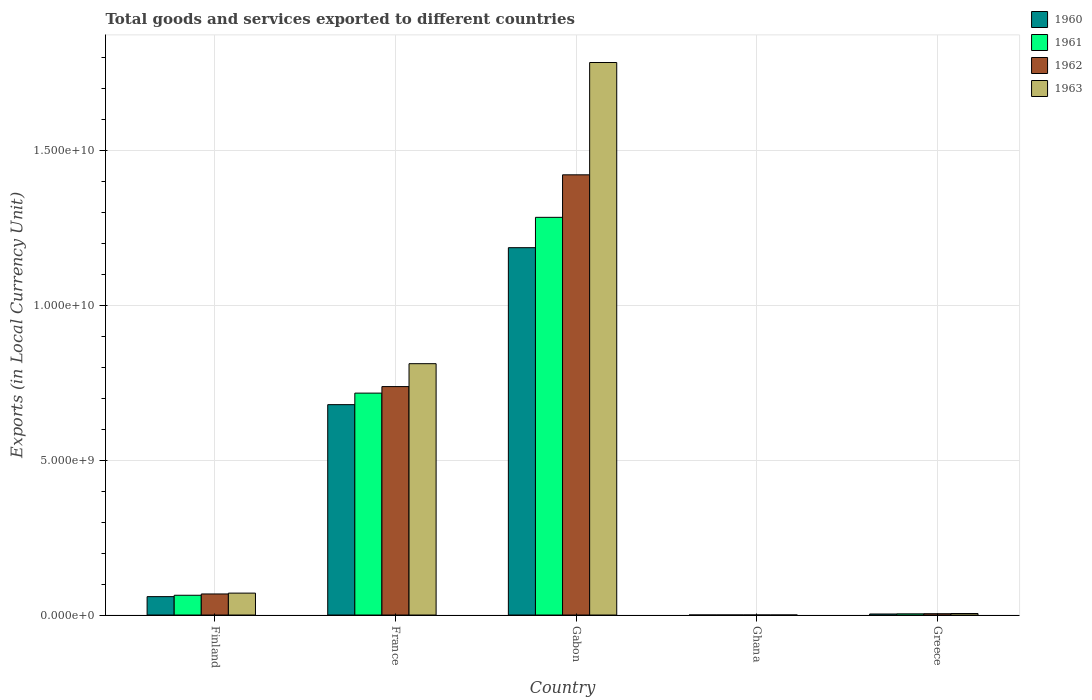How many different coloured bars are there?
Offer a very short reply. 4. Are the number of bars per tick equal to the number of legend labels?
Make the answer very short. Yes. In how many cases, is the number of bars for a given country not equal to the number of legend labels?
Your response must be concise. 0. What is the Amount of goods and services exports in 1963 in Greece?
Offer a very short reply. 4.90e+07. Across all countries, what is the maximum Amount of goods and services exports in 1962?
Offer a terse response. 1.42e+1. Across all countries, what is the minimum Amount of goods and services exports in 1961?
Your answer should be compact. 2.43e+04. In which country was the Amount of goods and services exports in 1963 maximum?
Offer a terse response. Gabon. What is the total Amount of goods and services exports in 1962 in the graph?
Your response must be concise. 2.23e+1. What is the difference between the Amount of goods and services exports in 1960 in Ghana and that in Greece?
Offer a terse response. -3.33e+07. What is the difference between the Amount of goods and services exports in 1962 in Gabon and the Amount of goods and services exports in 1963 in Finland?
Keep it short and to the point. 1.35e+1. What is the average Amount of goods and services exports in 1963 per country?
Your answer should be very brief. 5.34e+09. What is the difference between the Amount of goods and services exports of/in 1962 and Amount of goods and services exports of/in 1961 in France?
Ensure brevity in your answer.  2.11e+08. In how many countries, is the Amount of goods and services exports in 1963 greater than 8000000000 LCU?
Give a very brief answer. 2. What is the ratio of the Amount of goods and services exports in 1963 in Finland to that in Greece?
Offer a very short reply. 14.43. Is the Amount of goods and services exports in 1961 in France less than that in Gabon?
Keep it short and to the point. Yes. What is the difference between the highest and the second highest Amount of goods and services exports in 1960?
Make the answer very short. 6.19e+09. What is the difference between the highest and the lowest Amount of goods and services exports in 1960?
Your response must be concise. 1.19e+1. What does the 2nd bar from the left in Ghana represents?
Give a very brief answer. 1961. Is it the case that in every country, the sum of the Amount of goods and services exports in 1961 and Amount of goods and services exports in 1960 is greater than the Amount of goods and services exports in 1962?
Provide a short and direct response. Yes. Are the values on the major ticks of Y-axis written in scientific E-notation?
Your response must be concise. Yes. Does the graph contain any zero values?
Offer a very short reply. No. Does the graph contain grids?
Give a very brief answer. Yes. Where does the legend appear in the graph?
Provide a succinct answer. Top right. How are the legend labels stacked?
Give a very brief answer. Vertical. What is the title of the graph?
Make the answer very short. Total goods and services exported to different countries. What is the label or title of the Y-axis?
Your response must be concise. Exports (in Local Currency Unit). What is the Exports (in Local Currency Unit) in 1960 in Finland?
Provide a succinct answer. 5.94e+08. What is the Exports (in Local Currency Unit) in 1961 in Finland?
Give a very brief answer. 6.38e+08. What is the Exports (in Local Currency Unit) of 1962 in Finland?
Your answer should be very brief. 6.80e+08. What is the Exports (in Local Currency Unit) in 1963 in Finland?
Make the answer very short. 7.07e+08. What is the Exports (in Local Currency Unit) of 1960 in France?
Provide a succinct answer. 6.79e+09. What is the Exports (in Local Currency Unit) of 1961 in France?
Offer a very short reply. 7.16e+09. What is the Exports (in Local Currency Unit) in 1962 in France?
Provide a short and direct response. 7.37e+09. What is the Exports (in Local Currency Unit) in 1963 in France?
Offer a terse response. 8.11e+09. What is the Exports (in Local Currency Unit) in 1960 in Gabon?
Give a very brief answer. 1.19e+1. What is the Exports (in Local Currency Unit) of 1961 in Gabon?
Keep it short and to the point. 1.28e+1. What is the Exports (in Local Currency Unit) in 1962 in Gabon?
Offer a very short reply. 1.42e+1. What is the Exports (in Local Currency Unit) of 1963 in Gabon?
Provide a short and direct response. 1.78e+1. What is the Exports (in Local Currency Unit) in 1960 in Ghana?
Make the answer very short. 2.45e+04. What is the Exports (in Local Currency Unit) of 1961 in Ghana?
Your answer should be compact. 2.43e+04. What is the Exports (in Local Currency Unit) in 1962 in Ghana?
Your answer should be very brief. 2.39e+04. What is the Exports (in Local Currency Unit) in 1963 in Ghana?
Offer a terse response. 2.33e+04. What is the Exports (in Local Currency Unit) in 1960 in Greece?
Provide a short and direct response. 3.33e+07. What is the Exports (in Local Currency Unit) of 1961 in Greece?
Offer a very short reply. 3.82e+07. What is the Exports (in Local Currency Unit) of 1962 in Greece?
Make the answer very short. 4.25e+07. What is the Exports (in Local Currency Unit) of 1963 in Greece?
Your answer should be compact. 4.90e+07. Across all countries, what is the maximum Exports (in Local Currency Unit) of 1960?
Your response must be concise. 1.19e+1. Across all countries, what is the maximum Exports (in Local Currency Unit) of 1961?
Offer a terse response. 1.28e+1. Across all countries, what is the maximum Exports (in Local Currency Unit) in 1962?
Give a very brief answer. 1.42e+1. Across all countries, what is the maximum Exports (in Local Currency Unit) in 1963?
Provide a short and direct response. 1.78e+1. Across all countries, what is the minimum Exports (in Local Currency Unit) of 1960?
Your answer should be compact. 2.45e+04. Across all countries, what is the minimum Exports (in Local Currency Unit) in 1961?
Offer a terse response. 2.43e+04. Across all countries, what is the minimum Exports (in Local Currency Unit) of 1962?
Give a very brief answer. 2.39e+04. Across all countries, what is the minimum Exports (in Local Currency Unit) in 1963?
Give a very brief answer. 2.33e+04. What is the total Exports (in Local Currency Unit) in 1960 in the graph?
Keep it short and to the point. 1.93e+1. What is the total Exports (in Local Currency Unit) in 1961 in the graph?
Your answer should be compact. 2.07e+1. What is the total Exports (in Local Currency Unit) of 1962 in the graph?
Give a very brief answer. 2.23e+1. What is the total Exports (in Local Currency Unit) in 1963 in the graph?
Your answer should be very brief. 2.67e+1. What is the difference between the Exports (in Local Currency Unit) of 1960 in Finland and that in France?
Offer a very short reply. -6.19e+09. What is the difference between the Exports (in Local Currency Unit) of 1961 in Finland and that in France?
Your answer should be compact. -6.52e+09. What is the difference between the Exports (in Local Currency Unit) in 1962 in Finland and that in France?
Keep it short and to the point. -6.69e+09. What is the difference between the Exports (in Local Currency Unit) of 1963 in Finland and that in France?
Make the answer very short. -7.40e+09. What is the difference between the Exports (in Local Currency Unit) of 1960 in Finland and that in Gabon?
Offer a terse response. -1.13e+1. What is the difference between the Exports (in Local Currency Unit) of 1961 in Finland and that in Gabon?
Provide a short and direct response. -1.22e+1. What is the difference between the Exports (in Local Currency Unit) of 1962 in Finland and that in Gabon?
Ensure brevity in your answer.  -1.35e+1. What is the difference between the Exports (in Local Currency Unit) of 1963 in Finland and that in Gabon?
Your answer should be compact. -1.71e+1. What is the difference between the Exports (in Local Currency Unit) of 1960 in Finland and that in Ghana?
Offer a terse response. 5.94e+08. What is the difference between the Exports (in Local Currency Unit) in 1961 in Finland and that in Ghana?
Your response must be concise. 6.38e+08. What is the difference between the Exports (in Local Currency Unit) in 1962 in Finland and that in Ghana?
Your response must be concise. 6.80e+08. What is the difference between the Exports (in Local Currency Unit) of 1963 in Finland and that in Ghana?
Your answer should be very brief. 7.07e+08. What is the difference between the Exports (in Local Currency Unit) in 1960 in Finland and that in Greece?
Offer a terse response. 5.60e+08. What is the difference between the Exports (in Local Currency Unit) of 1961 in Finland and that in Greece?
Give a very brief answer. 5.99e+08. What is the difference between the Exports (in Local Currency Unit) in 1962 in Finland and that in Greece?
Your answer should be compact. 6.37e+08. What is the difference between the Exports (in Local Currency Unit) of 1963 in Finland and that in Greece?
Give a very brief answer. 6.58e+08. What is the difference between the Exports (in Local Currency Unit) in 1960 in France and that in Gabon?
Your answer should be compact. -5.06e+09. What is the difference between the Exports (in Local Currency Unit) in 1961 in France and that in Gabon?
Offer a very short reply. -5.67e+09. What is the difference between the Exports (in Local Currency Unit) in 1962 in France and that in Gabon?
Provide a short and direct response. -6.83e+09. What is the difference between the Exports (in Local Currency Unit) of 1963 in France and that in Gabon?
Your answer should be compact. -9.72e+09. What is the difference between the Exports (in Local Currency Unit) of 1960 in France and that in Ghana?
Provide a short and direct response. 6.79e+09. What is the difference between the Exports (in Local Currency Unit) of 1961 in France and that in Ghana?
Keep it short and to the point. 7.16e+09. What is the difference between the Exports (in Local Currency Unit) of 1962 in France and that in Ghana?
Offer a terse response. 7.37e+09. What is the difference between the Exports (in Local Currency Unit) in 1963 in France and that in Ghana?
Make the answer very short. 8.11e+09. What is the difference between the Exports (in Local Currency Unit) of 1960 in France and that in Greece?
Offer a very short reply. 6.76e+09. What is the difference between the Exports (in Local Currency Unit) in 1961 in France and that in Greece?
Offer a very short reply. 7.12e+09. What is the difference between the Exports (in Local Currency Unit) in 1962 in France and that in Greece?
Offer a very short reply. 7.33e+09. What is the difference between the Exports (in Local Currency Unit) of 1963 in France and that in Greece?
Keep it short and to the point. 8.06e+09. What is the difference between the Exports (in Local Currency Unit) in 1960 in Gabon and that in Ghana?
Make the answer very short. 1.19e+1. What is the difference between the Exports (in Local Currency Unit) of 1961 in Gabon and that in Ghana?
Offer a terse response. 1.28e+1. What is the difference between the Exports (in Local Currency Unit) in 1962 in Gabon and that in Ghana?
Keep it short and to the point. 1.42e+1. What is the difference between the Exports (in Local Currency Unit) in 1963 in Gabon and that in Ghana?
Make the answer very short. 1.78e+1. What is the difference between the Exports (in Local Currency Unit) of 1960 in Gabon and that in Greece?
Provide a succinct answer. 1.18e+1. What is the difference between the Exports (in Local Currency Unit) of 1961 in Gabon and that in Greece?
Your answer should be very brief. 1.28e+1. What is the difference between the Exports (in Local Currency Unit) in 1962 in Gabon and that in Greece?
Your answer should be compact. 1.42e+1. What is the difference between the Exports (in Local Currency Unit) in 1963 in Gabon and that in Greece?
Your answer should be very brief. 1.78e+1. What is the difference between the Exports (in Local Currency Unit) of 1960 in Ghana and that in Greece?
Your answer should be compact. -3.33e+07. What is the difference between the Exports (in Local Currency Unit) in 1961 in Ghana and that in Greece?
Give a very brief answer. -3.82e+07. What is the difference between the Exports (in Local Currency Unit) of 1962 in Ghana and that in Greece?
Your response must be concise. -4.25e+07. What is the difference between the Exports (in Local Currency Unit) of 1963 in Ghana and that in Greece?
Ensure brevity in your answer.  -4.90e+07. What is the difference between the Exports (in Local Currency Unit) in 1960 in Finland and the Exports (in Local Currency Unit) in 1961 in France?
Your response must be concise. -6.57e+09. What is the difference between the Exports (in Local Currency Unit) in 1960 in Finland and the Exports (in Local Currency Unit) in 1962 in France?
Offer a very short reply. -6.78e+09. What is the difference between the Exports (in Local Currency Unit) of 1960 in Finland and the Exports (in Local Currency Unit) of 1963 in France?
Keep it short and to the point. -7.52e+09. What is the difference between the Exports (in Local Currency Unit) in 1961 in Finland and the Exports (in Local Currency Unit) in 1962 in France?
Provide a short and direct response. -6.73e+09. What is the difference between the Exports (in Local Currency Unit) of 1961 in Finland and the Exports (in Local Currency Unit) of 1963 in France?
Ensure brevity in your answer.  -7.47e+09. What is the difference between the Exports (in Local Currency Unit) in 1962 in Finland and the Exports (in Local Currency Unit) in 1963 in France?
Provide a short and direct response. -7.43e+09. What is the difference between the Exports (in Local Currency Unit) of 1960 in Finland and the Exports (in Local Currency Unit) of 1961 in Gabon?
Provide a short and direct response. -1.22e+1. What is the difference between the Exports (in Local Currency Unit) of 1960 in Finland and the Exports (in Local Currency Unit) of 1962 in Gabon?
Provide a succinct answer. -1.36e+1. What is the difference between the Exports (in Local Currency Unit) of 1960 in Finland and the Exports (in Local Currency Unit) of 1963 in Gabon?
Give a very brief answer. -1.72e+1. What is the difference between the Exports (in Local Currency Unit) in 1961 in Finland and the Exports (in Local Currency Unit) in 1962 in Gabon?
Ensure brevity in your answer.  -1.36e+1. What is the difference between the Exports (in Local Currency Unit) of 1961 in Finland and the Exports (in Local Currency Unit) of 1963 in Gabon?
Offer a terse response. -1.72e+1. What is the difference between the Exports (in Local Currency Unit) of 1962 in Finland and the Exports (in Local Currency Unit) of 1963 in Gabon?
Provide a succinct answer. -1.71e+1. What is the difference between the Exports (in Local Currency Unit) of 1960 in Finland and the Exports (in Local Currency Unit) of 1961 in Ghana?
Provide a succinct answer. 5.94e+08. What is the difference between the Exports (in Local Currency Unit) in 1960 in Finland and the Exports (in Local Currency Unit) in 1962 in Ghana?
Offer a terse response. 5.94e+08. What is the difference between the Exports (in Local Currency Unit) in 1960 in Finland and the Exports (in Local Currency Unit) in 1963 in Ghana?
Make the answer very short. 5.94e+08. What is the difference between the Exports (in Local Currency Unit) of 1961 in Finland and the Exports (in Local Currency Unit) of 1962 in Ghana?
Provide a succinct answer. 6.38e+08. What is the difference between the Exports (in Local Currency Unit) in 1961 in Finland and the Exports (in Local Currency Unit) in 1963 in Ghana?
Your answer should be very brief. 6.38e+08. What is the difference between the Exports (in Local Currency Unit) of 1962 in Finland and the Exports (in Local Currency Unit) of 1963 in Ghana?
Keep it short and to the point. 6.80e+08. What is the difference between the Exports (in Local Currency Unit) of 1960 in Finland and the Exports (in Local Currency Unit) of 1961 in Greece?
Your answer should be compact. 5.55e+08. What is the difference between the Exports (in Local Currency Unit) in 1960 in Finland and the Exports (in Local Currency Unit) in 1962 in Greece?
Make the answer very short. 5.51e+08. What is the difference between the Exports (in Local Currency Unit) of 1960 in Finland and the Exports (in Local Currency Unit) of 1963 in Greece?
Ensure brevity in your answer.  5.45e+08. What is the difference between the Exports (in Local Currency Unit) of 1961 in Finland and the Exports (in Local Currency Unit) of 1962 in Greece?
Make the answer very short. 5.95e+08. What is the difference between the Exports (in Local Currency Unit) of 1961 in Finland and the Exports (in Local Currency Unit) of 1963 in Greece?
Provide a short and direct response. 5.89e+08. What is the difference between the Exports (in Local Currency Unit) of 1962 in Finland and the Exports (in Local Currency Unit) of 1963 in Greece?
Make the answer very short. 6.31e+08. What is the difference between the Exports (in Local Currency Unit) of 1960 in France and the Exports (in Local Currency Unit) of 1961 in Gabon?
Keep it short and to the point. -6.04e+09. What is the difference between the Exports (in Local Currency Unit) of 1960 in France and the Exports (in Local Currency Unit) of 1962 in Gabon?
Keep it short and to the point. -7.42e+09. What is the difference between the Exports (in Local Currency Unit) of 1960 in France and the Exports (in Local Currency Unit) of 1963 in Gabon?
Ensure brevity in your answer.  -1.10e+1. What is the difference between the Exports (in Local Currency Unit) of 1961 in France and the Exports (in Local Currency Unit) of 1962 in Gabon?
Offer a very short reply. -7.04e+09. What is the difference between the Exports (in Local Currency Unit) in 1961 in France and the Exports (in Local Currency Unit) in 1963 in Gabon?
Offer a terse response. -1.07e+1. What is the difference between the Exports (in Local Currency Unit) in 1962 in France and the Exports (in Local Currency Unit) in 1963 in Gabon?
Your answer should be very brief. -1.05e+1. What is the difference between the Exports (in Local Currency Unit) in 1960 in France and the Exports (in Local Currency Unit) in 1961 in Ghana?
Offer a very short reply. 6.79e+09. What is the difference between the Exports (in Local Currency Unit) of 1960 in France and the Exports (in Local Currency Unit) of 1962 in Ghana?
Your response must be concise. 6.79e+09. What is the difference between the Exports (in Local Currency Unit) in 1960 in France and the Exports (in Local Currency Unit) in 1963 in Ghana?
Keep it short and to the point. 6.79e+09. What is the difference between the Exports (in Local Currency Unit) of 1961 in France and the Exports (in Local Currency Unit) of 1962 in Ghana?
Give a very brief answer. 7.16e+09. What is the difference between the Exports (in Local Currency Unit) of 1961 in France and the Exports (in Local Currency Unit) of 1963 in Ghana?
Provide a short and direct response. 7.16e+09. What is the difference between the Exports (in Local Currency Unit) in 1962 in France and the Exports (in Local Currency Unit) in 1963 in Ghana?
Provide a short and direct response. 7.37e+09. What is the difference between the Exports (in Local Currency Unit) of 1960 in France and the Exports (in Local Currency Unit) of 1961 in Greece?
Ensure brevity in your answer.  6.75e+09. What is the difference between the Exports (in Local Currency Unit) in 1960 in France and the Exports (in Local Currency Unit) in 1962 in Greece?
Ensure brevity in your answer.  6.75e+09. What is the difference between the Exports (in Local Currency Unit) in 1960 in France and the Exports (in Local Currency Unit) in 1963 in Greece?
Offer a very short reply. 6.74e+09. What is the difference between the Exports (in Local Currency Unit) in 1961 in France and the Exports (in Local Currency Unit) in 1962 in Greece?
Ensure brevity in your answer.  7.12e+09. What is the difference between the Exports (in Local Currency Unit) of 1961 in France and the Exports (in Local Currency Unit) of 1963 in Greece?
Keep it short and to the point. 7.11e+09. What is the difference between the Exports (in Local Currency Unit) of 1962 in France and the Exports (in Local Currency Unit) of 1963 in Greece?
Your answer should be very brief. 7.32e+09. What is the difference between the Exports (in Local Currency Unit) of 1960 in Gabon and the Exports (in Local Currency Unit) of 1961 in Ghana?
Offer a terse response. 1.19e+1. What is the difference between the Exports (in Local Currency Unit) in 1960 in Gabon and the Exports (in Local Currency Unit) in 1962 in Ghana?
Give a very brief answer. 1.19e+1. What is the difference between the Exports (in Local Currency Unit) in 1960 in Gabon and the Exports (in Local Currency Unit) in 1963 in Ghana?
Provide a short and direct response. 1.19e+1. What is the difference between the Exports (in Local Currency Unit) in 1961 in Gabon and the Exports (in Local Currency Unit) in 1962 in Ghana?
Your response must be concise. 1.28e+1. What is the difference between the Exports (in Local Currency Unit) in 1961 in Gabon and the Exports (in Local Currency Unit) in 1963 in Ghana?
Your answer should be compact. 1.28e+1. What is the difference between the Exports (in Local Currency Unit) in 1962 in Gabon and the Exports (in Local Currency Unit) in 1963 in Ghana?
Your response must be concise. 1.42e+1. What is the difference between the Exports (in Local Currency Unit) in 1960 in Gabon and the Exports (in Local Currency Unit) in 1961 in Greece?
Offer a terse response. 1.18e+1. What is the difference between the Exports (in Local Currency Unit) of 1960 in Gabon and the Exports (in Local Currency Unit) of 1962 in Greece?
Provide a succinct answer. 1.18e+1. What is the difference between the Exports (in Local Currency Unit) of 1960 in Gabon and the Exports (in Local Currency Unit) of 1963 in Greece?
Your response must be concise. 1.18e+1. What is the difference between the Exports (in Local Currency Unit) of 1961 in Gabon and the Exports (in Local Currency Unit) of 1962 in Greece?
Ensure brevity in your answer.  1.28e+1. What is the difference between the Exports (in Local Currency Unit) in 1961 in Gabon and the Exports (in Local Currency Unit) in 1963 in Greece?
Provide a succinct answer. 1.28e+1. What is the difference between the Exports (in Local Currency Unit) in 1962 in Gabon and the Exports (in Local Currency Unit) in 1963 in Greece?
Make the answer very short. 1.42e+1. What is the difference between the Exports (in Local Currency Unit) in 1960 in Ghana and the Exports (in Local Currency Unit) in 1961 in Greece?
Keep it short and to the point. -3.82e+07. What is the difference between the Exports (in Local Currency Unit) of 1960 in Ghana and the Exports (in Local Currency Unit) of 1962 in Greece?
Your answer should be compact. -4.25e+07. What is the difference between the Exports (in Local Currency Unit) in 1960 in Ghana and the Exports (in Local Currency Unit) in 1963 in Greece?
Your answer should be compact. -4.90e+07. What is the difference between the Exports (in Local Currency Unit) in 1961 in Ghana and the Exports (in Local Currency Unit) in 1962 in Greece?
Provide a succinct answer. -4.25e+07. What is the difference between the Exports (in Local Currency Unit) in 1961 in Ghana and the Exports (in Local Currency Unit) in 1963 in Greece?
Make the answer very short. -4.90e+07. What is the difference between the Exports (in Local Currency Unit) in 1962 in Ghana and the Exports (in Local Currency Unit) in 1963 in Greece?
Your answer should be very brief. -4.90e+07. What is the average Exports (in Local Currency Unit) in 1960 per country?
Give a very brief answer. 3.85e+09. What is the average Exports (in Local Currency Unit) of 1961 per country?
Give a very brief answer. 4.13e+09. What is the average Exports (in Local Currency Unit) of 1962 per country?
Provide a short and direct response. 4.46e+09. What is the average Exports (in Local Currency Unit) in 1963 per country?
Offer a very short reply. 5.34e+09. What is the difference between the Exports (in Local Currency Unit) of 1960 and Exports (in Local Currency Unit) of 1961 in Finland?
Provide a short and direct response. -4.42e+07. What is the difference between the Exports (in Local Currency Unit) in 1960 and Exports (in Local Currency Unit) in 1962 in Finland?
Keep it short and to the point. -8.63e+07. What is the difference between the Exports (in Local Currency Unit) in 1960 and Exports (in Local Currency Unit) in 1963 in Finland?
Your answer should be very brief. -1.13e+08. What is the difference between the Exports (in Local Currency Unit) in 1961 and Exports (in Local Currency Unit) in 1962 in Finland?
Offer a very short reply. -4.21e+07. What is the difference between the Exports (in Local Currency Unit) of 1961 and Exports (in Local Currency Unit) of 1963 in Finland?
Give a very brief answer. -6.91e+07. What is the difference between the Exports (in Local Currency Unit) of 1962 and Exports (in Local Currency Unit) of 1963 in Finland?
Keep it short and to the point. -2.71e+07. What is the difference between the Exports (in Local Currency Unit) in 1960 and Exports (in Local Currency Unit) in 1961 in France?
Your response must be concise. -3.72e+08. What is the difference between the Exports (in Local Currency Unit) of 1960 and Exports (in Local Currency Unit) of 1962 in France?
Make the answer very short. -5.82e+08. What is the difference between the Exports (in Local Currency Unit) in 1960 and Exports (in Local Currency Unit) in 1963 in France?
Give a very brief answer. -1.32e+09. What is the difference between the Exports (in Local Currency Unit) of 1961 and Exports (in Local Currency Unit) of 1962 in France?
Make the answer very short. -2.11e+08. What is the difference between the Exports (in Local Currency Unit) in 1961 and Exports (in Local Currency Unit) in 1963 in France?
Ensure brevity in your answer.  -9.50e+08. What is the difference between the Exports (in Local Currency Unit) of 1962 and Exports (in Local Currency Unit) of 1963 in France?
Ensure brevity in your answer.  -7.39e+08. What is the difference between the Exports (in Local Currency Unit) in 1960 and Exports (in Local Currency Unit) in 1961 in Gabon?
Offer a terse response. -9.80e+08. What is the difference between the Exports (in Local Currency Unit) of 1960 and Exports (in Local Currency Unit) of 1962 in Gabon?
Provide a succinct answer. -2.35e+09. What is the difference between the Exports (in Local Currency Unit) of 1960 and Exports (in Local Currency Unit) of 1963 in Gabon?
Provide a succinct answer. -5.98e+09. What is the difference between the Exports (in Local Currency Unit) of 1961 and Exports (in Local Currency Unit) of 1962 in Gabon?
Provide a short and direct response. -1.37e+09. What is the difference between the Exports (in Local Currency Unit) in 1961 and Exports (in Local Currency Unit) in 1963 in Gabon?
Your answer should be very brief. -5.00e+09. What is the difference between the Exports (in Local Currency Unit) in 1962 and Exports (in Local Currency Unit) in 1963 in Gabon?
Your response must be concise. -3.62e+09. What is the difference between the Exports (in Local Currency Unit) of 1960 and Exports (in Local Currency Unit) of 1961 in Ghana?
Your answer should be very brief. 200. What is the difference between the Exports (in Local Currency Unit) of 1960 and Exports (in Local Currency Unit) of 1962 in Ghana?
Provide a short and direct response. 600. What is the difference between the Exports (in Local Currency Unit) of 1960 and Exports (in Local Currency Unit) of 1963 in Ghana?
Provide a short and direct response. 1200. What is the difference between the Exports (in Local Currency Unit) in 1961 and Exports (in Local Currency Unit) in 1962 in Ghana?
Your answer should be very brief. 400. What is the difference between the Exports (in Local Currency Unit) of 1961 and Exports (in Local Currency Unit) of 1963 in Ghana?
Offer a terse response. 1000. What is the difference between the Exports (in Local Currency Unit) of 1962 and Exports (in Local Currency Unit) of 1963 in Ghana?
Give a very brief answer. 600. What is the difference between the Exports (in Local Currency Unit) of 1960 and Exports (in Local Currency Unit) of 1961 in Greece?
Give a very brief answer. -4.90e+06. What is the difference between the Exports (in Local Currency Unit) in 1960 and Exports (in Local Currency Unit) in 1962 in Greece?
Offer a terse response. -9.19e+06. What is the difference between the Exports (in Local Currency Unit) of 1960 and Exports (in Local Currency Unit) of 1963 in Greece?
Ensure brevity in your answer.  -1.57e+07. What is the difference between the Exports (in Local Currency Unit) in 1961 and Exports (in Local Currency Unit) in 1962 in Greece?
Offer a very short reply. -4.29e+06. What is the difference between the Exports (in Local Currency Unit) of 1961 and Exports (in Local Currency Unit) of 1963 in Greece?
Make the answer very short. -1.08e+07. What is the difference between the Exports (in Local Currency Unit) in 1962 and Exports (in Local Currency Unit) in 1963 in Greece?
Offer a very short reply. -6.47e+06. What is the ratio of the Exports (in Local Currency Unit) of 1960 in Finland to that in France?
Your response must be concise. 0.09. What is the ratio of the Exports (in Local Currency Unit) of 1961 in Finland to that in France?
Offer a terse response. 0.09. What is the ratio of the Exports (in Local Currency Unit) in 1962 in Finland to that in France?
Give a very brief answer. 0.09. What is the ratio of the Exports (in Local Currency Unit) of 1963 in Finland to that in France?
Offer a terse response. 0.09. What is the ratio of the Exports (in Local Currency Unit) in 1960 in Finland to that in Gabon?
Your answer should be very brief. 0.05. What is the ratio of the Exports (in Local Currency Unit) of 1961 in Finland to that in Gabon?
Give a very brief answer. 0.05. What is the ratio of the Exports (in Local Currency Unit) in 1962 in Finland to that in Gabon?
Offer a terse response. 0.05. What is the ratio of the Exports (in Local Currency Unit) in 1963 in Finland to that in Gabon?
Offer a terse response. 0.04. What is the ratio of the Exports (in Local Currency Unit) in 1960 in Finland to that in Ghana?
Offer a terse response. 2.42e+04. What is the ratio of the Exports (in Local Currency Unit) of 1961 in Finland to that in Ghana?
Provide a short and direct response. 2.62e+04. What is the ratio of the Exports (in Local Currency Unit) in 1962 in Finland to that in Ghana?
Make the answer very short. 2.84e+04. What is the ratio of the Exports (in Local Currency Unit) in 1963 in Finland to that in Ghana?
Your answer should be very brief. 3.03e+04. What is the ratio of the Exports (in Local Currency Unit) of 1960 in Finland to that in Greece?
Your answer should be compact. 17.81. What is the ratio of the Exports (in Local Currency Unit) of 1961 in Finland to that in Greece?
Make the answer very short. 16.69. What is the ratio of the Exports (in Local Currency Unit) in 1962 in Finland to that in Greece?
Your response must be concise. 15.99. What is the ratio of the Exports (in Local Currency Unit) of 1963 in Finland to that in Greece?
Offer a very short reply. 14.43. What is the ratio of the Exports (in Local Currency Unit) of 1960 in France to that in Gabon?
Keep it short and to the point. 0.57. What is the ratio of the Exports (in Local Currency Unit) of 1961 in France to that in Gabon?
Provide a succinct answer. 0.56. What is the ratio of the Exports (in Local Currency Unit) in 1962 in France to that in Gabon?
Give a very brief answer. 0.52. What is the ratio of the Exports (in Local Currency Unit) in 1963 in France to that in Gabon?
Provide a succinct answer. 0.45. What is the ratio of the Exports (in Local Currency Unit) in 1960 in France to that in Ghana?
Ensure brevity in your answer.  2.77e+05. What is the ratio of the Exports (in Local Currency Unit) in 1961 in France to that in Ghana?
Ensure brevity in your answer.  2.95e+05. What is the ratio of the Exports (in Local Currency Unit) in 1962 in France to that in Ghana?
Provide a succinct answer. 3.08e+05. What is the ratio of the Exports (in Local Currency Unit) of 1963 in France to that in Ghana?
Your answer should be compact. 3.48e+05. What is the ratio of the Exports (in Local Currency Unit) of 1960 in France to that in Greece?
Provide a succinct answer. 203.73. What is the ratio of the Exports (in Local Currency Unit) in 1961 in France to that in Greece?
Ensure brevity in your answer.  187.34. What is the ratio of the Exports (in Local Currency Unit) in 1962 in France to that in Greece?
Offer a very short reply. 173.41. What is the ratio of the Exports (in Local Currency Unit) of 1963 in France to that in Greece?
Give a very brief answer. 165.59. What is the ratio of the Exports (in Local Currency Unit) in 1960 in Gabon to that in Ghana?
Provide a succinct answer. 4.84e+05. What is the ratio of the Exports (in Local Currency Unit) of 1961 in Gabon to that in Ghana?
Your answer should be compact. 5.28e+05. What is the ratio of the Exports (in Local Currency Unit) in 1962 in Gabon to that in Ghana?
Your response must be concise. 5.94e+05. What is the ratio of the Exports (in Local Currency Unit) in 1963 in Gabon to that in Ghana?
Ensure brevity in your answer.  7.65e+05. What is the ratio of the Exports (in Local Currency Unit) in 1960 in Gabon to that in Greece?
Provide a short and direct response. 355.72. What is the ratio of the Exports (in Local Currency Unit) in 1961 in Gabon to that in Greece?
Your response must be concise. 335.76. What is the ratio of the Exports (in Local Currency Unit) of 1962 in Gabon to that in Greece?
Provide a succinct answer. 334.16. What is the ratio of the Exports (in Local Currency Unit) in 1963 in Gabon to that in Greece?
Give a very brief answer. 364.01. What is the ratio of the Exports (in Local Currency Unit) in 1960 in Ghana to that in Greece?
Provide a succinct answer. 0. What is the ratio of the Exports (in Local Currency Unit) in 1961 in Ghana to that in Greece?
Make the answer very short. 0. What is the ratio of the Exports (in Local Currency Unit) of 1962 in Ghana to that in Greece?
Offer a very short reply. 0. What is the difference between the highest and the second highest Exports (in Local Currency Unit) of 1960?
Offer a very short reply. 5.06e+09. What is the difference between the highest and the second highest Exports (in Local Currency Unit) in 1961?
Give a very brief answer. 5.67e+09. What is the difference between the highest and the second highest Exports (in Local Currency Unit) in 1962?
Your response must be concise. 6.83e+09. What is the difference between the highest and the second highest Exports (in Local Currency Unit) of 1963?
Give a very brief answer. 9.72e+09. What is the difference between the highest and the lowest Exports (in Local Currency Unit) in 1960?
Provide a succinct answer. 1.19e+1. What is the difference between the highest and the lowest Exports (in Local Currency Unit) in 1961?
Make the answer very short. 1.28e+1. What is the difference between the highest and the lowest Exports (in Local Currency Unit) in 1962?
Offer a very short reply. 1.42e+1. What is the difference between the highest and the lowest Exports (in Local Currency Unit) of 1963?
Give a very brief answer. 1.78e+1. 